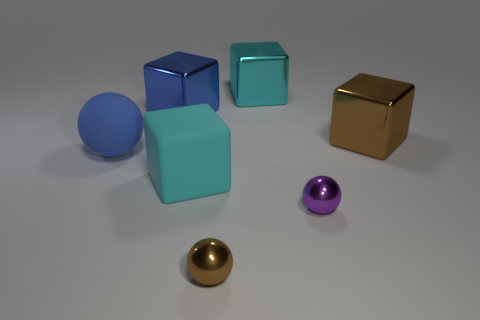Can you describe the lighting and mood of the scene? The lighting in the image is soft and diffused, casting gentle shadows and giving the scene a calm, still atmosphere. There's an almost studio-quality setup suggesting a controlled environment, which creates a neutral mood with a focus on the objects themselves. 